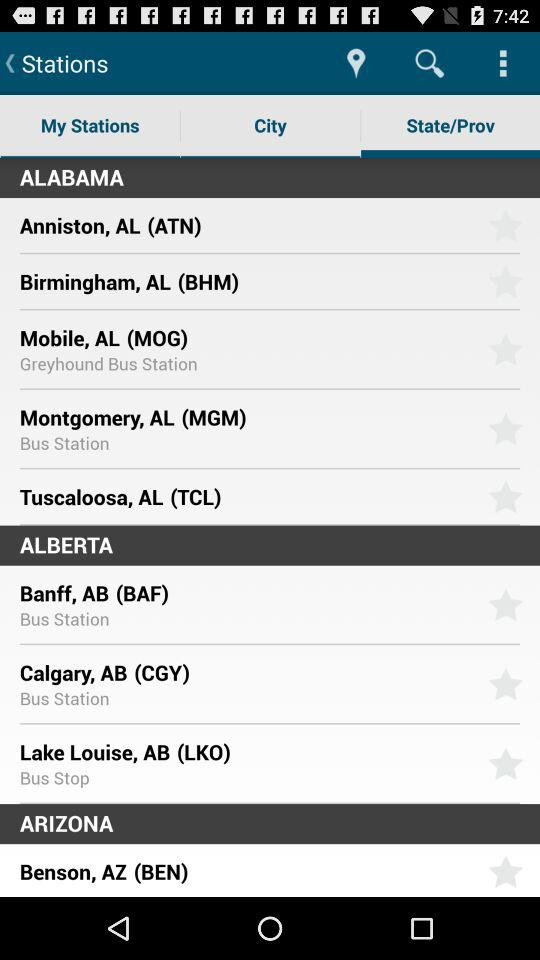How many more items are in the Alabama section than the Arizona section?
Answer the question using a single word or phrase. 4 